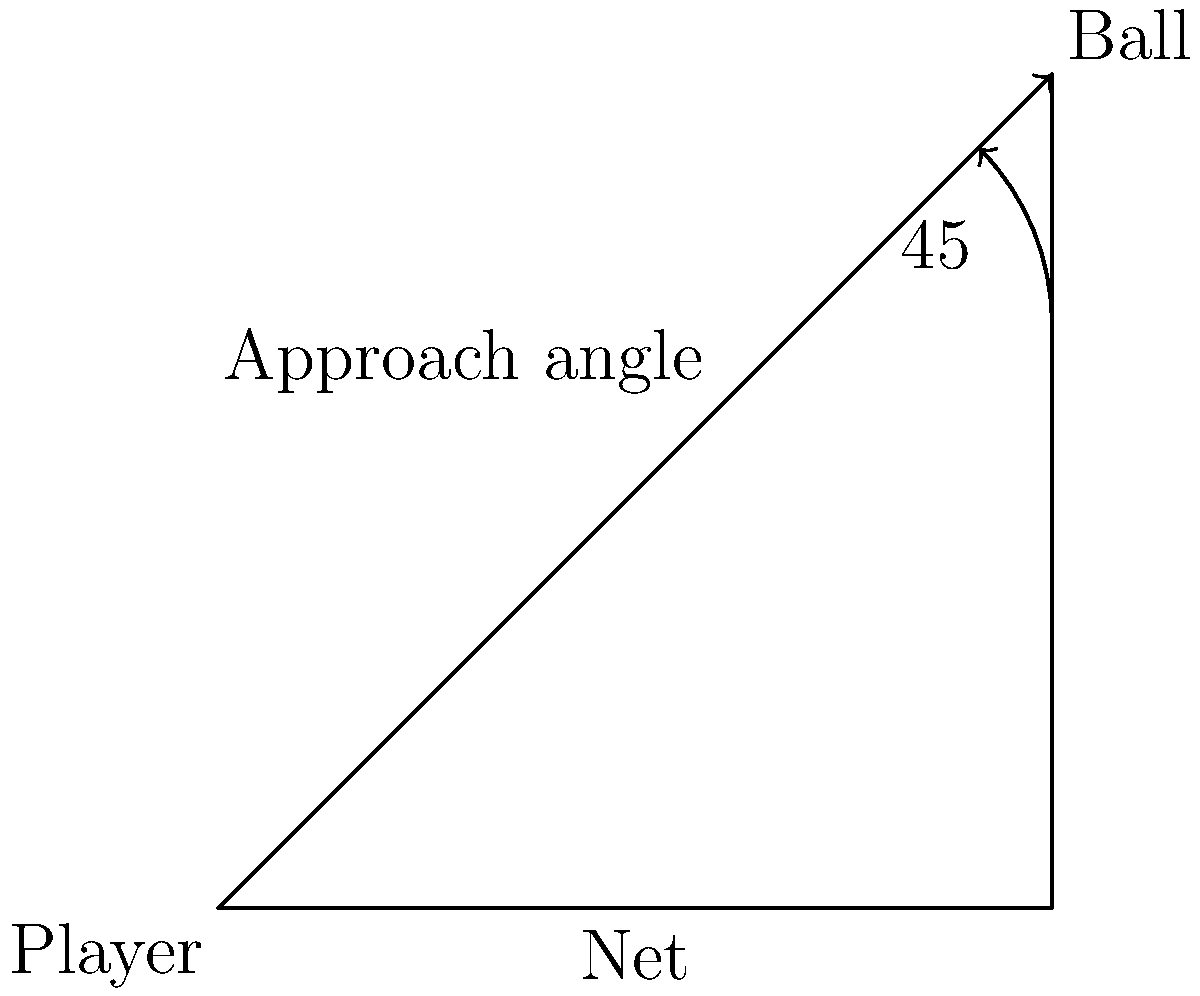As a tennis player known for your innovative style, you understand the importance of approach angles in various tennis strokes. In the diagram, a player is approaching the ball at a 45° angle to the net. How does this angle affect the player's ability to execute an effective cross-court shot compared to a down-the-line shot? To analyze the effectiveness of the 45° approach angle for cross-court and down-the-line shots, let's consider the following steps:

1. Angle of approach: The player is approaching the ball at a 45° angle to the net. This is a balanced angle that allows for various shot options.

2. Cross-court shot:
   a) The 45° angle aligns well with the natural trajectory of a cross-court shot.
   b) It allows the player to open up their stance, facilitating a full swing.
   c) The player can use their body rotation to generate power and spin.
   d) The ball travels over the lowest part of the net, reducing the risk of errors.

3. Down-the-line shot:
   a) The 45° angle is not ideal for a down-the-line shot, as it requires a more significant adjustment in the player's body position.
   b) The player needs to close their stance or rotate their upper body more to hit down the line.
   c) There's a higher risk of the ball hitting the net, as it travels over a higher part of the net.
   d) The shot requires more precise timing and control.

4. Effectiveness comparison:
   a) Cross-court: More natural, easier to execute, lower risk, and potentially more powerful.
   b) Down-the-line: More challenging, requires better technique, higher risk, but can be a surprise element.

5. Strategic implications:
   a) The 45° angle gives the player options, keeping the opponent guessing.
   b) It allows for last-minute decision-making based on the opponent's position.

In conclusion, the 45° approach angle is more conducive to an effective cross-court shot, offering a better balance of power, control, and risk management. However, a skilled player can still execute a down-the-line shot from this angle, albeit with more difficulty and risk.
Answer: The 45° approach angle is more effective for cross-court shots due to natural alignment, easier execution, and lower risk, while down-the-line shots are more challenging but still possible with proper technique. 